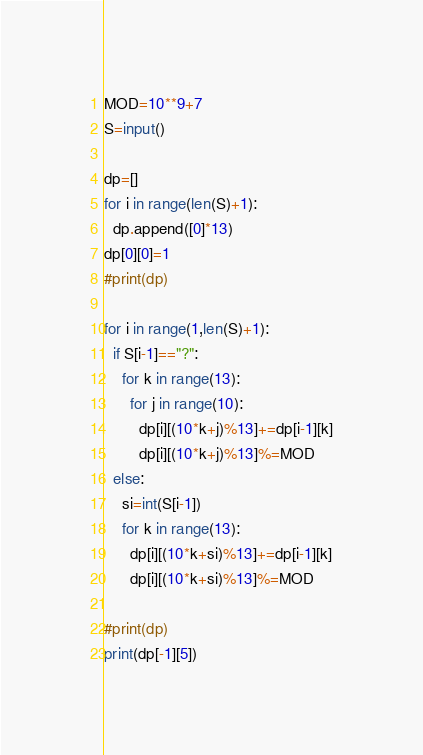Convert code to text. <code><loc_0><loc_0><loc_500><loc_500><_Python_>MOD=10**9+7
S=input()

dp=[]
for i in range(len(S)+1):
  dp.append([0]*13)
dp[0][0]=1
#print(dp)

for i in range(1,len(S)+1):
  if S[i-1]=="?":
    for k in range(13):
      for j in range(10):
        dp[i][(10*k+j)%13]+=dp[i-1][k]
        dp[i][(10*k+j)%13]%=MOD
  else:
    si=int(S[i-1])
    for k in range(13):
      dp[i][(10*k+si)%13]+=dp[i-1][k]
      dp[i][(10*k+si)%13]%=MOD
    
#print(dp)
print(dp[-1][5])</code> 